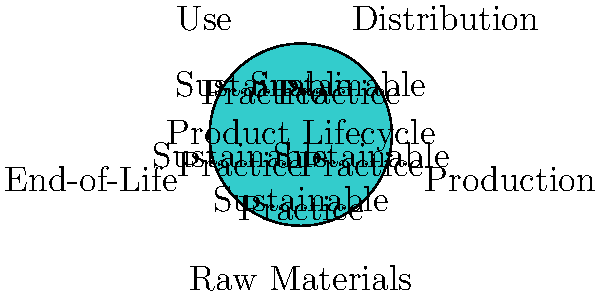In the product lifecycle diagram, which stage is most likely to involve recycling programs and biodegradable packaging to minimize environmental impact? To answer this question, we need to analyze each stage of the product lifecycle and consider which one would be most appropriate for implementing recycling programs and biodegradable packaging:

1. Raw Materials: This stage focuses on sourcing materials, not disposing of them.
2. Production: This stage involves manufacturing the product, not its packaging or disposal.
3. Distribution: This stage is about transporting the product to retailers or consumers.
4. Use: This stage represents the consumer's use of the product.
5. End-of-Life: This stage deals with what happens to the product after its useful life is over.

Recycling programs and biodegradable packaging are most relevant to the End-of-Life stage because:
1. Recycling programs are implemented to manage products after they've been used and discarded.
2. Biodegradable packaging is designed to break down naturally at the end of the product's life.

These practices aim to minimize the environmental impact of products once they're no longer useful, which aligns with the goals of the End-of-Life stage in a sustainable product lifecycle.
Answer: End-of-Life 